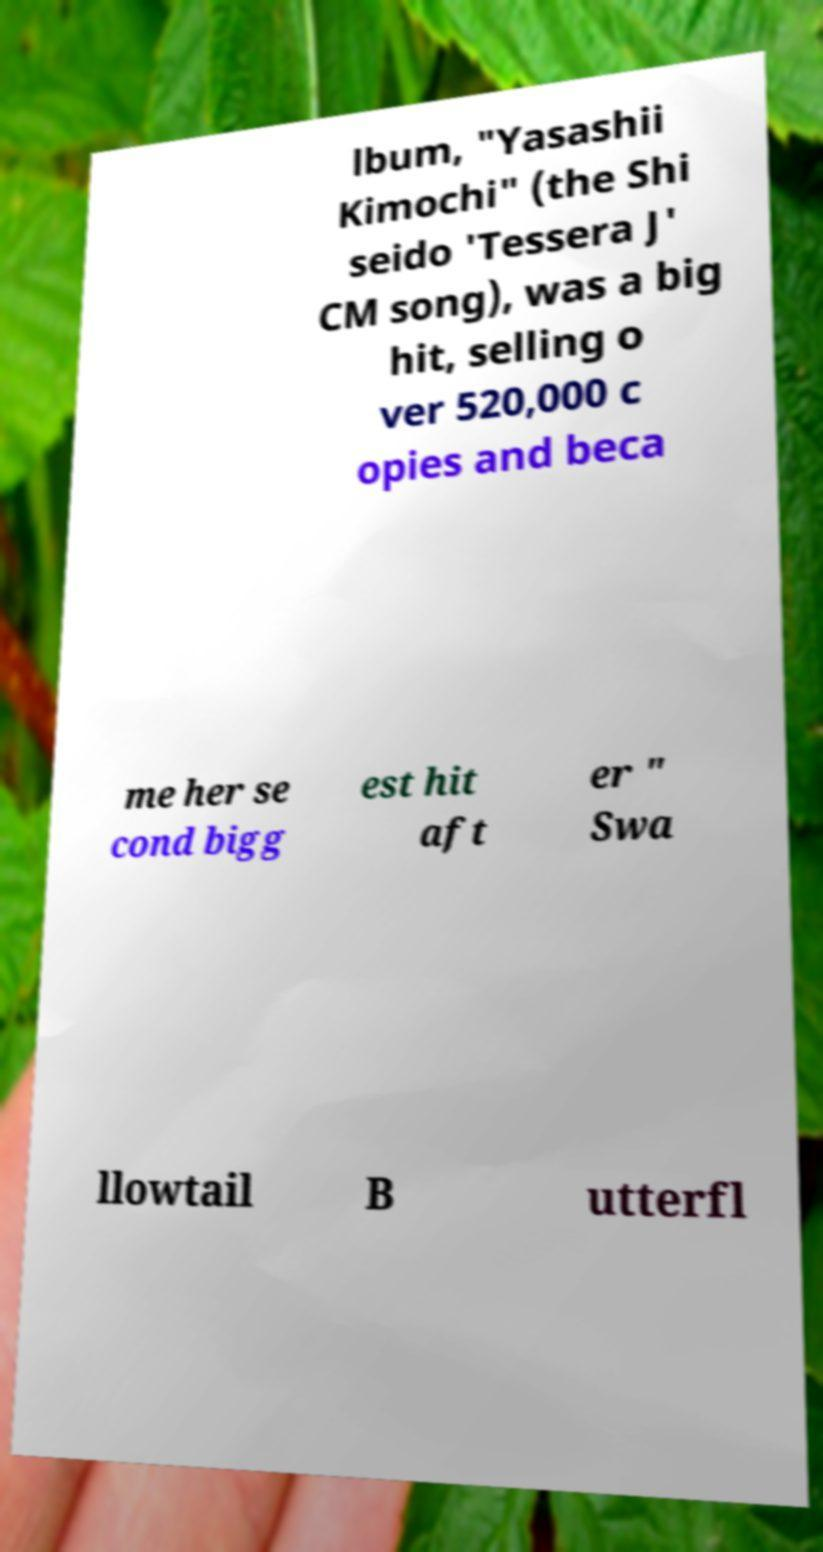Could you assist in decoding the text presented in this image and type it out clearly? lbum, "Yasashii Kimochi" (the Shi seido 'Tessera J' CM song), was a big hit, selling o ver 520,000 c opies and beca me her se cond bigg est hit aft er " Swa llowtail B utterfl 